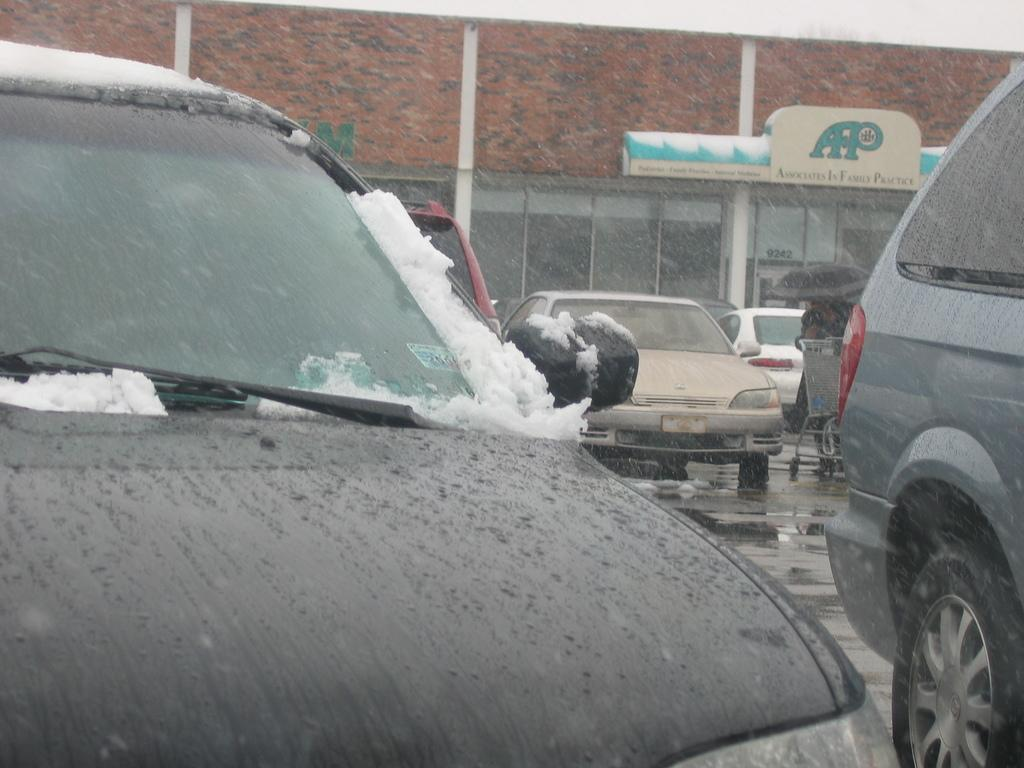What type of vehicles can be seen on the road in the image? There are cars on the road in the image. What natural element is visible in the image? There is water visible in the image. What weather condition is depicted in the image? There is snow in the image. What object might be used for protection from the weather in the image? There is an umbrella in the image. What type of structure can be seen in the background of the image? There is a building in the background of the image. What type of vessel can be seen carrying books in the image? There is no vessel or books present in the image. How many bananas are visible in the image? There are no bananas present in the image. 